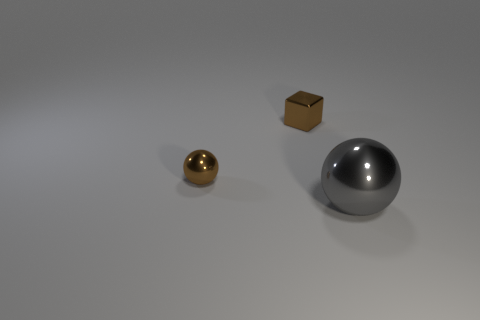What is the shape of the thing that is the same color as the metallic cube?
Keep it short and to the point. Sphere. Is the shape of the metallic object in front of the brown metal sphere the same as the shiny object that is to the left of the tiny block?
Give a very brief answer. Yes. There is a gray object; are there any metallic things on the right side of it?
Provide a short and direct response. No. What color is the tiny thing that is the same shape as the large object?
Provide a short and direct response. Brown. What is the ball to the left of the gray metal thing made of?
Provide a succinct answer. Metal. What is the size of the other metallic object that is the same shape as the big gray thing?
Offer a very short reply. Small. What number of cubes have the same material as the gray object?
Provide a short and direct response. 1. What number of other small balls have the same color as the small ball?
Your response must be concise. 0. What number of objects are either metallic balls that are to the left of the large shiny sphere or small things in front of the block?
Your answer should be compact. 1. Are there fewer big spheres to the left of the big thing than tiny blocks?
Provide a short and direct response. Yes. 